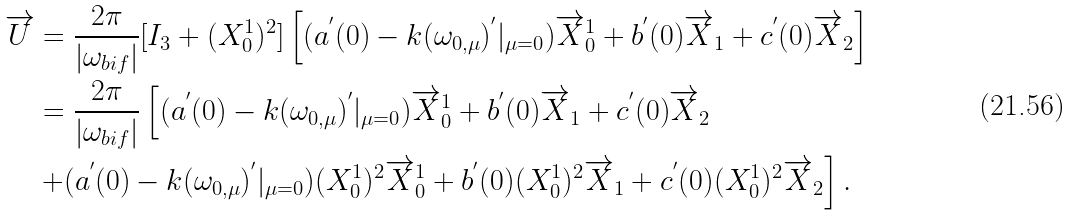<formula> <loc_0><loc_0><loc_500><loc_500>\overrightarrow { U } & = \frac { 2 \pi } { \left | \omega _ { b i f } \right | } [ I _ { 3 } + ( X _ { 0 } ^ { 1 } ) ^ { 2 } ] \left [ ( a ^ { ^ { \prime } } ( 0 ) - k ( \omega _ { 0 , \mu } ) ^ { ^ { \prime } } | _ { \mu = 0 } ) \overrightarrow { X } _ { 0 } ^ { 1 } + b ^ { ^ { \prime } } ( 0 ) \overrightarrow { X } _ { 1 } + c ^ { ^ { \prime } } ( 0 ) \overrightarrow { X } _ { 2 } \right ] \\ & = \frac { 2 \pi } { \left | \omega _ { b i f } \right | } \left [ ( a ^ { ^ { \prime } } ( 0 ) - k ( \omega _ { 0 , \mu } ) ^ { ^ { \prime } } | _ { \mu = 0 } ) \overrightarrow { X } _ { 0 } ^ { 1 } + b ^ { ^ { \prime } } ( 0 ) \overrightarrow { X } _ { 1 } + c ^ { ^ { \prime } } ( 0 ) \overrightarrow { X } _ { 2 } \right . \\ & \left . + ( a ^ { ^ { \prime } } ( 0 ) - k ( \omega _ { 0 , \mu } ) ^ { ^ { \prime } } | _ { \mu = 0 } ) ( X _ { 0 } ^ { 1 } ) ^ { 2 } \overrightarrow { X } _ { 0 } ^ { 1 } + b ^ { ^ { \prime } } ( 0 ) ( X _ { 0 } ^ { 1 } ) ^ { 2 } \overrightarrow { X } _ { 1 } + c ^ { ^ { \prime } } ( 0 ) ( X _ { 0 } ^ { 1 } ) ^ { 2 } \overrightarrow { X } _ { 2 } \right ] .</formula> 